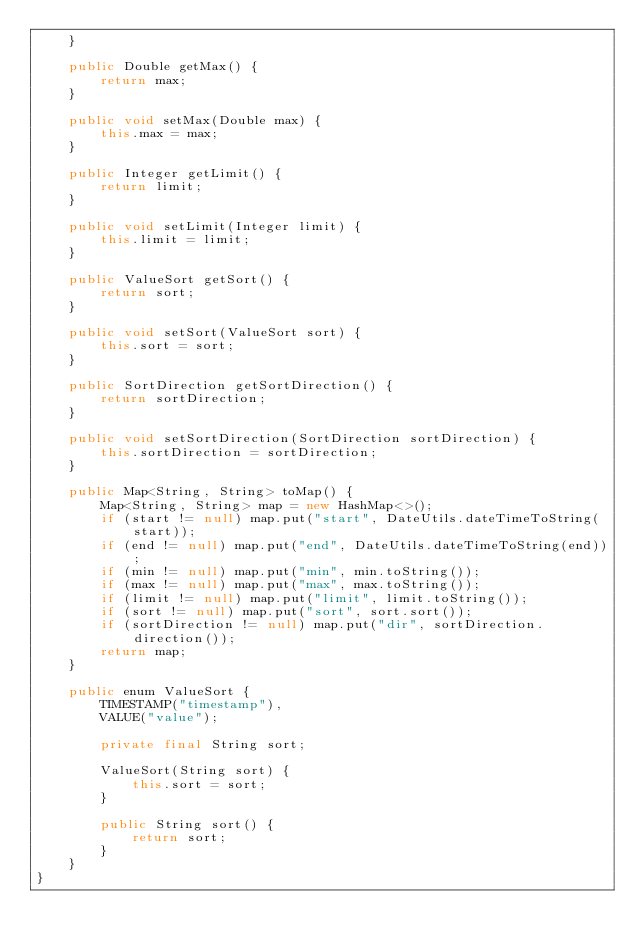Convert code to text. <code><loc_0><loc_0><loc_500><loc_500><_Java_>    }

    public Double getMax() {
        return max;
    }

    public void setMax(Double max) {
        this.max = max;
    }

    public Integer getLimit() {
        return limit;
    }

    public void setLimit(Integer limit) {
        this.limit = limit;
    }

    public ValueSort getSort() {
        return sort;
    }

    public void setSort(ValueSort sort) {
        this.sort = sort;
    }

    public SortDirection getSortDirection() {
        return sortDirection;
    }

    public void setSortDirection(SortDirection sortDirection) {
        this.sortDirection = sortDirection;
    }

    public Map<String, String> toMap() {
        Map<String, String> map = new HashMap<>();
        if (start != null) map.put("start", DateUtils.dateTimeToString(start));
        if (end != null) map.put("end", DateUtils.dateTimeToString(end));
        if (min != null) map.put("min", min.toString());
        if (max != null) map.put("max", max.toString());
        if (limit != null) map.put("limit", limit.toString());
        if (sort != null) map.put("sort", sort.sort());
        if (sortDirection != null) map.put("dir", sortDirection.direction());
        return map;
    }

    public enum ValueSort {
        TIMESTAMP("timestamp"),
        VALUE("value");

        private final String sort;

        ValueSort(String sort) {
            this.sort = sort;
        }

        public String sort() {
            return sort;
        }
    }
}
</code> 